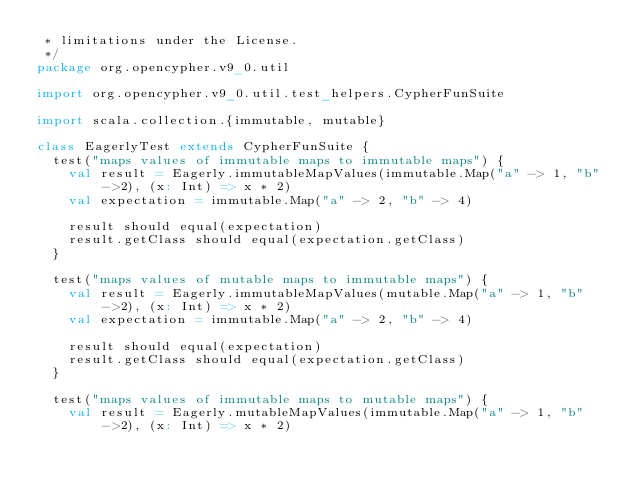<code> <loc_0><loc_0><loc_500><loc_500><_Scala_> * limitations under the License.
 */
package org.opencypher.v9_0.util

import org.opencypher.v9_0.util.test_helpers.CypherFunSuite

import scala.collection.{immutable, mutable}

class EagerlyTest extends CypherFunSuite {
  test("maps values of immutable maps to immutable maps") {
    val result = Eagerly.immutableMapValues(immutable.Map("a" -> 1, "b" ->2), (x: Int) => x * 2)
    val expectation = immutable.Map("a" -> 2, "b" -> 4)

    result should equal(expectation)
    result.getClass should equal(expectation.getClass)
  }

  test("maps values of mutable maps to immutable maps") {
    val result = Eagerly.immutableMapValues(mutable.Map("a" -> 1, "b" ->2), (x: Int) => x * 2)
    val expectation = immutable.Map("a" -> 2, "b" -> 4)

    result should equal(expectation)
    result.getClass should equal(expectation.getClass)
  }

  test("maps values of immutable maps to mutable maps") {
    val result = Eagerly.mutableMapValues(immutable.Map("a" -> 1, "b" ->2), (x: Int) => x * 2)</code> 